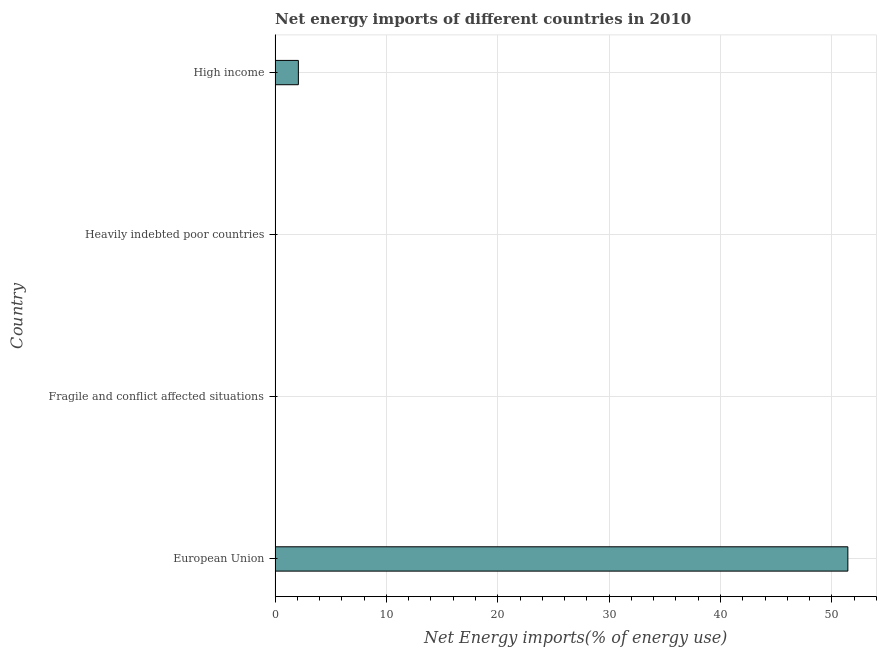What is the title of the graph?
Your answer should be very brief. Net energy imports of different countries in 2010. What is the label or title of the X-axis?
Your response must be concise. Net Energy imports(% of energy use). What is the label or title of the Y-axis?
Offer a very short reply. Country. Across all countries, what is the maximum energy imports?
Provide a short and direct response. 51.44. Across all countries, what is the minimum energy imports?
Your answer should be compact. 0. What is the sum of the energy imports?
Keep it short and to the point. 53.53. What is the difference between the energy imports in European Union and High income?
Offer a very short reply. 49.34. What is the average energy imports per country?
Give a very brief answer. 13.38. What is the median energy imports?
Keep it short and to the point. 1.05. What is the ratio of the energy imports in European Union to that in High income?
Your answer should be compact. 24.59. What is the difference between the highest and the lowest energy imports?
Make the answer very short. 51.44. In how many countries, is the energy imports greater than the average energy imports taken over all countries?
Provide a short and direct response. 1. How many bars are there?
Provide a succinct answer. 2. What is the Net Energy imports(% of energy use) in European Union?
Ensure brevity in your answer.  51.44. What is the Net Energy imports(% of energy use) in Fragile and conflict affected situations?
Give a very brief answer. 0. What is the Net Energy imports(% of energy use) of Heavily indebted poor countries?
Make the answer very short. 0. What is the Net Energy imports(% of energy use) of High income?
Your response must be concise. 2.09. What is the difference between the Net Energy imports(% of energy use) in European Union and High income?
Your response must be concise. 49.34. What is the ratio of the Net Energy imports(% of energy use) in European Union to that in High income?
Make the answer very short. 24.59. 